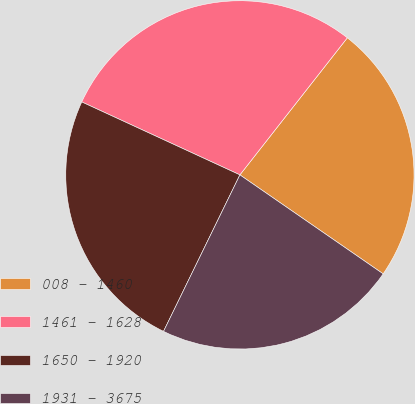Convert chart to OTSL. <chart><loc_0><loc_0><loc_500><loc_500><pie_chart><fcel>008 - 1460<fcel>1461 - 1628<fcel>1650 - 1920<fcel>1931 - 3675<nl><fcel>24.04%<fcel>28.7%<fcel>24.65%<fcel>22.6%<nl></chart> 